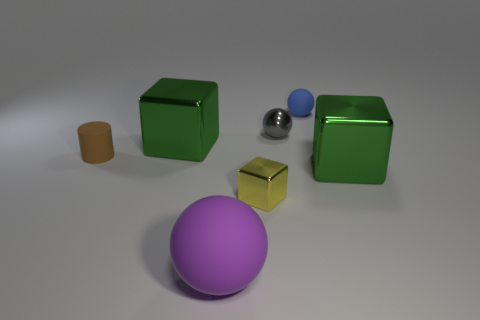What shape is the big object right of the big rubber thing on the right side of the big thing left of the purple matte thing?
Ensure brevity in your answer.  Cube. What number of small yellow shiny blocks are in front of the purple matte object?
Your response must be concise. 0. Are the cube that is left of the big sphere and the small blue sphere made of the same material?
Make the answer very short. No. What number of other objects are the same shape as the large purple thing?
Ensure brevity in your answer.  2. There is a big shiny cube that is in front of the big shiny block that is on the left side of the yellow metal object; what number of gray metal spheres are in front of it?
Your response must be concise. 0. There is a big thing on the right side of the small blue matte ball; what color is it?
Provide a short and direct response. Green. There is a small object that is to the left of the yellow thing; is it the same color as the small metallic sphere?
Offer a terse response. No. There is another blue object that is the same shape as the big matte thing; what is its size?
Provide a succinct answer. Small. Are there any other things that have the same size as the brown rubber cylinder?
Keep it short and to the point. Yes. What material is the green block that is behind the green metal thing that is to the right of the rubber sphere behind the purple matte object?
Provide a short and direct response. Metal. 